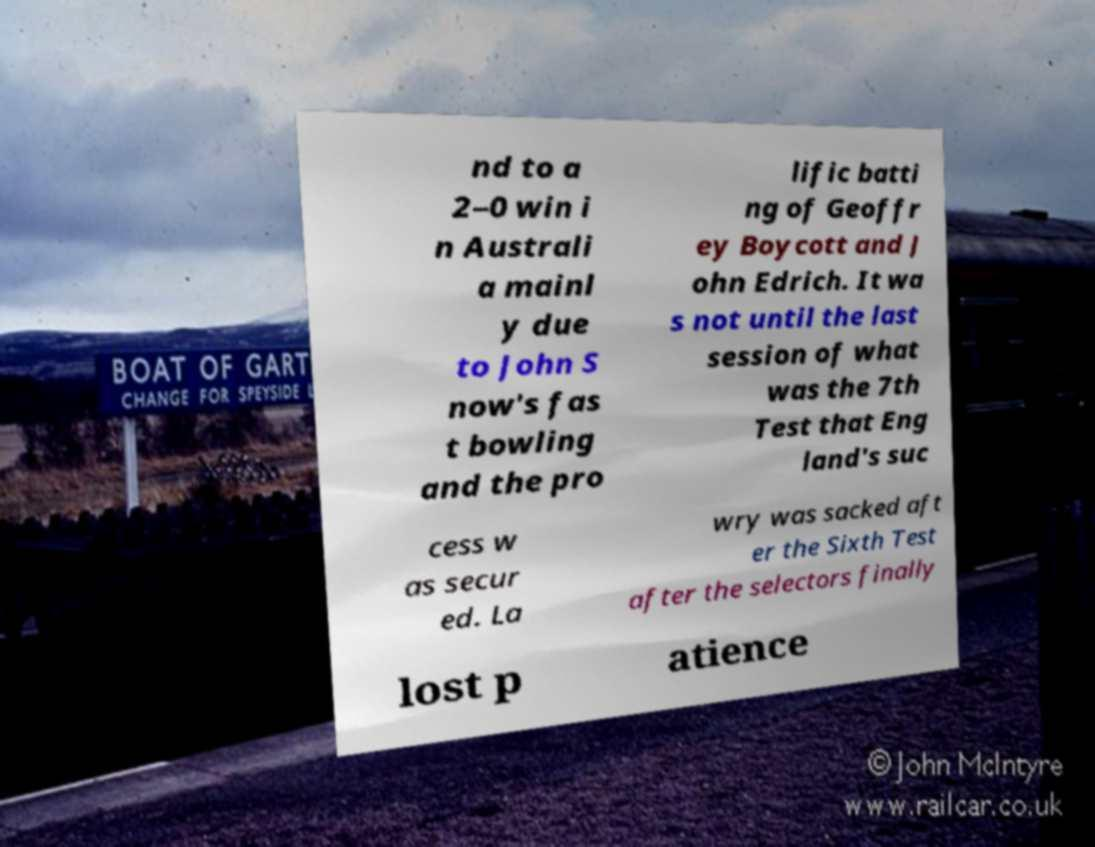Could you assist in decoding the text presented in this image and type it out clearly? nd to a 2–0 win i n Australi a mainl y due to John S now's fas t bowling and the pro lific batti ng of Geoffr ey Boycott and J ohn Edrich. It wa s not until the last session of what was the 7th Test that Eng land's suc cess w as secur ed. La wry was sacked aft er the Sixth Test after the selectors finally lost p atience 